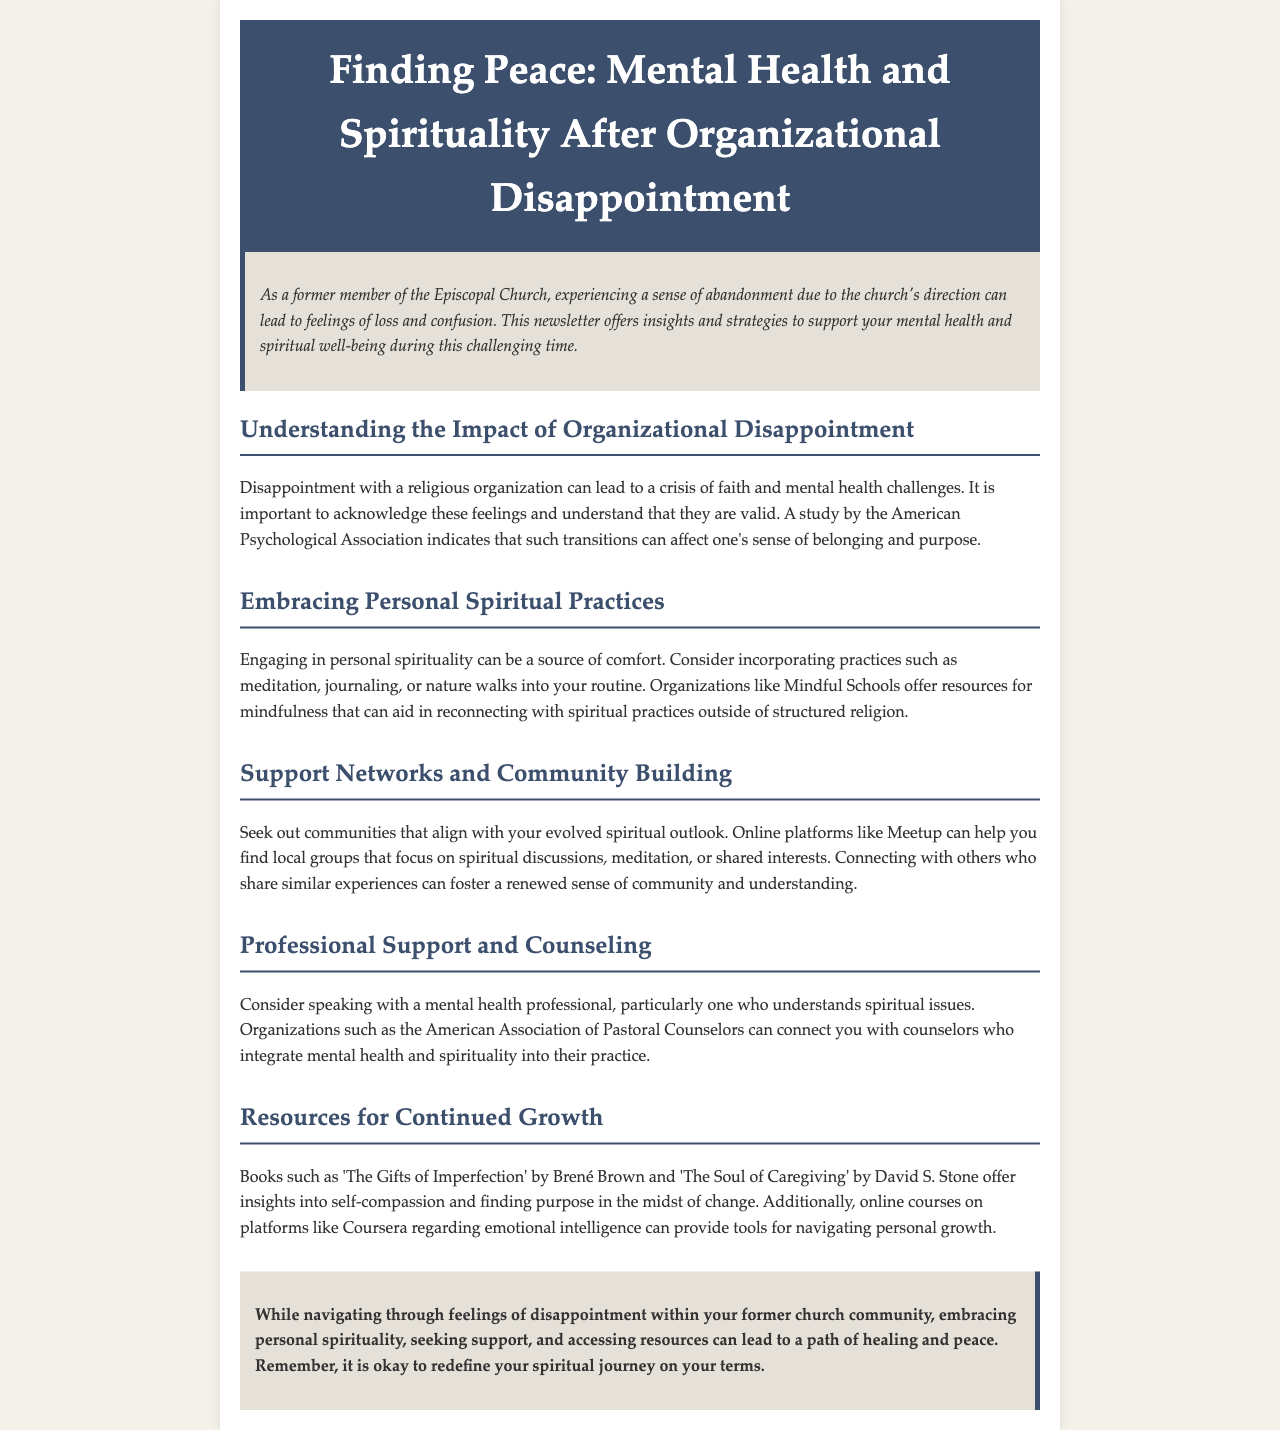What is the title of the newsletter? The title of the newsletter is found in the header section.
Answer: Finding Peace: Mental Health and Spirituality After Organizational Disappointment What organization conducted a study on the impact of organizational disappointment? The organization is mentioned in the section discussing understanding the impact of disappointment.
Answer: American Psychological Association What are three personal spiritual practices suggested in the newsletter? The practices are listed in the section about embracing personal spiritual practices.
Answer: meditation, journaling, nature walks Which organization can connect individuals with pastoral counselors? This organization is mentioned in the section on professional support and counseling.
Answer: American Association of Pastoral Counselors What type of resources does Mindful Schools offer? The type of resources is described in the section on embracing personal spiritual practices.
Answer: mindfulness What is one of the recommended books mentioned for continued growth? The book is listed in the section discussing resources for continued growth.
Answer: The Gifts of Imperfection What is emphasized as a valid feeling after disappointment? This concept is introduced in the section about understanding the impact of disappointment.
Answer: crisis of faith What aspect of community is encouraged in the newsletter? This aspect is discussed in the section about support networks.
Answer: connecting with others What does the conclusion encourage regarding spiritual journeys? The conclusion summarizes the overall message of the newsletter.
Answer: redefine your spiritual journey on your terms 